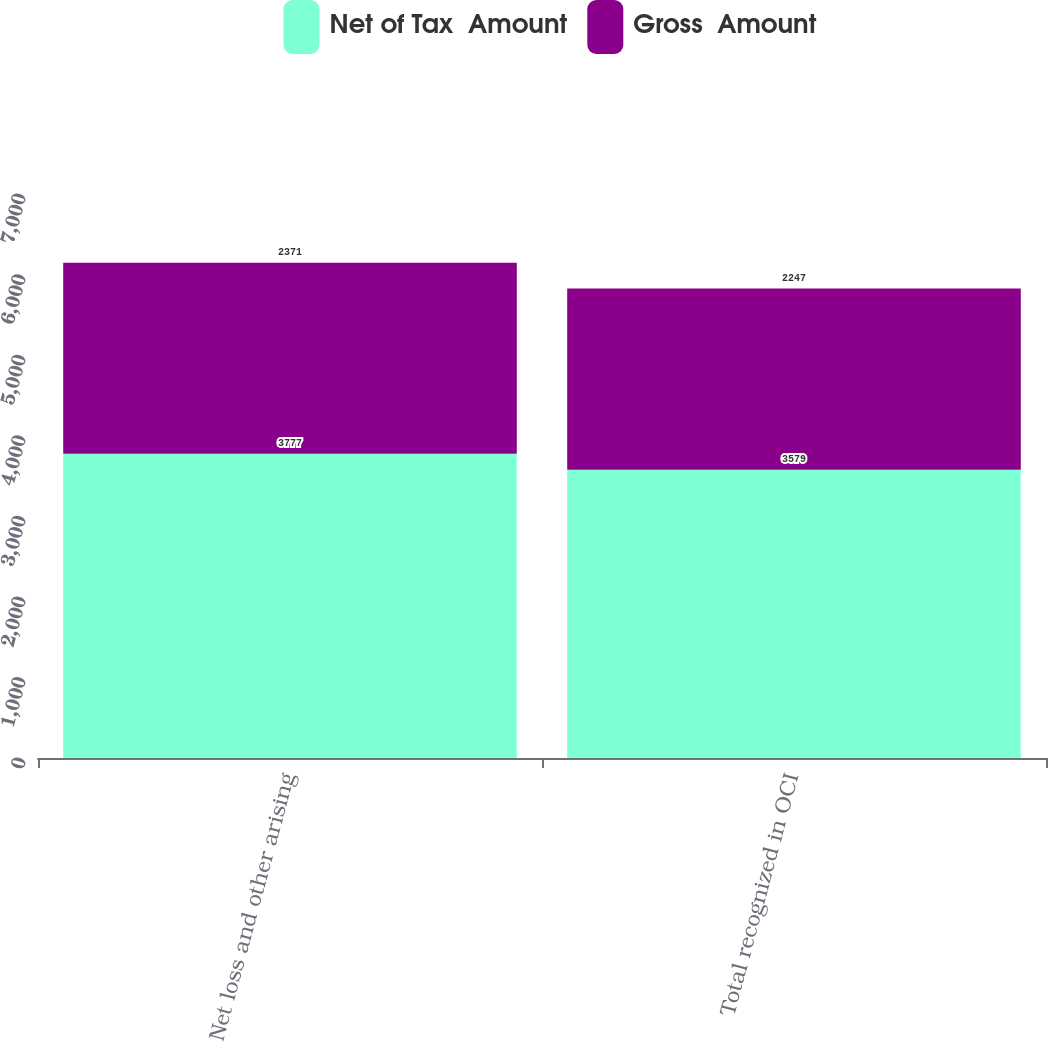Convert chart to OTSL. <chart><loc_0><loc_0><loc_500><loc_500><stacked_bar_chart><ecel><fcel>Net loss and other arising<fcel>Total recognized in OCI<nl><fcel>Net of Tax  Amount<fcel>3777<fcel>3579<nl><fcel>Gross  Amount<fcel>2371<fcel>2247<nl></chart> 